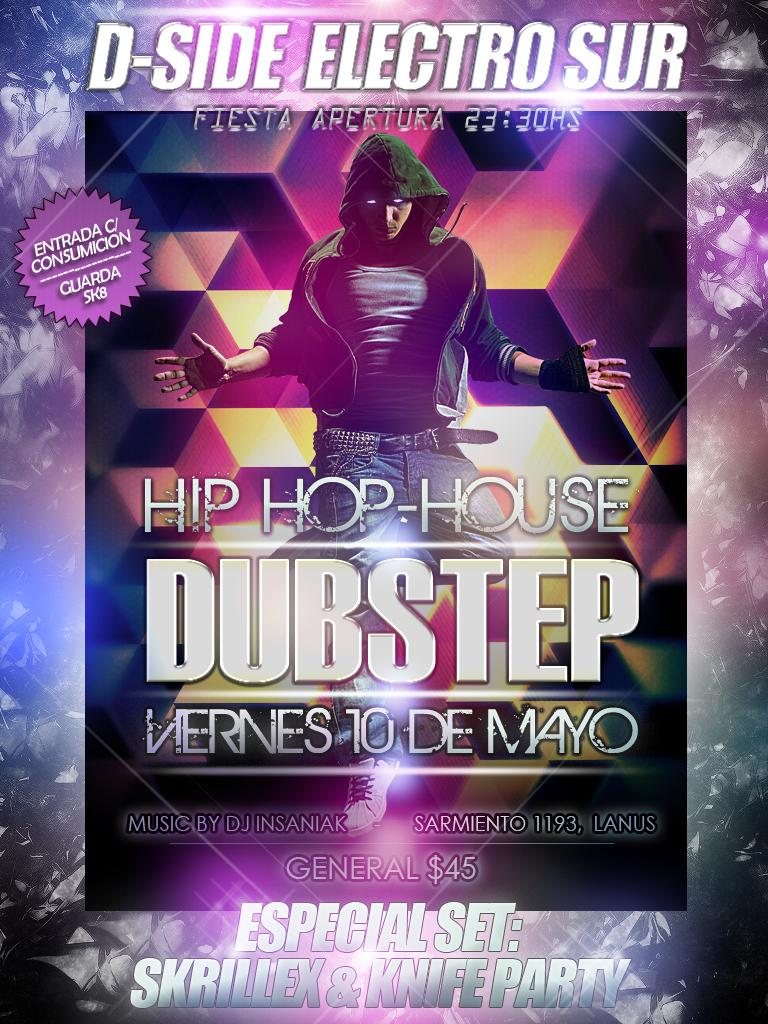Provide a one-sentence caption for the provided image. The show being advertised on the poster is call Hip Hop-House and admission cost $45.00. 